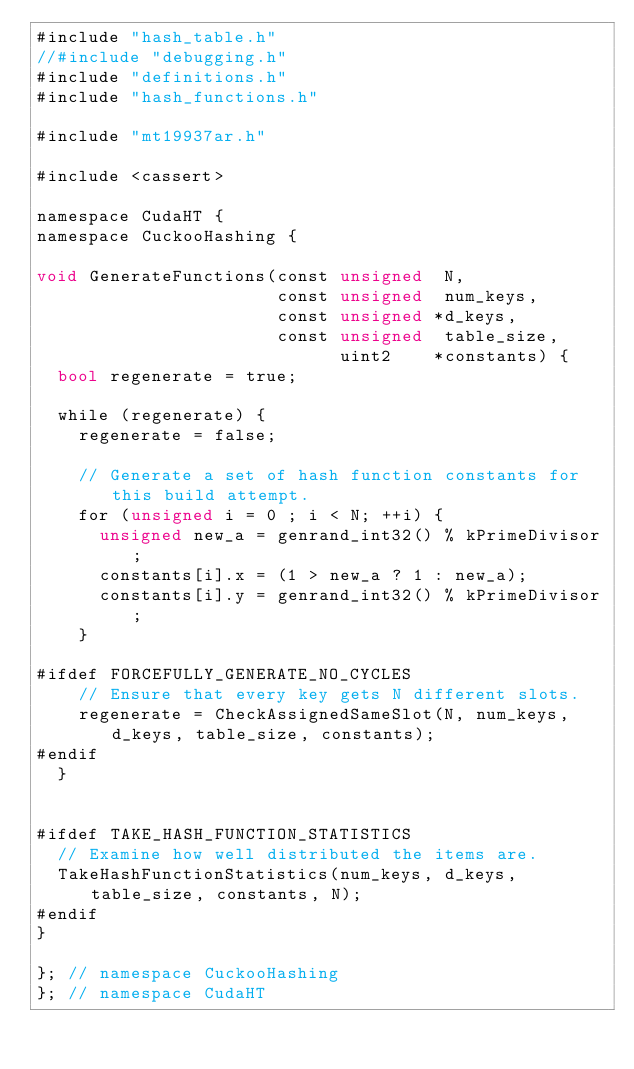Convert code to text. <code><loc_0><loc_0><loc_500><loc_500><_Cuda_>#include "hash_table.h"
//#include "debugging.h"
#include "definitions.h"
#include "hash_functions.h"

#include "mt19937ar.h"

#include <cassert>

namespace CudaHT {
namespace CuckooHashing {

void GenerateFunctions(const unsigned  N,
                       const unsigned  num_keys,
                       const unsigned *d_keys,
                       const unsigned  table_size,
                             uint2    *constants) {
  bool regenerate = true;

  while (regenerate) {
    regenerate = false;

    // Generate a set of hash function constants for this build attempt.
    for (unsigned i = 0 ; i < N; ++i) {
      unsigned new_a = genrand_int32() % kPrimeDivisor;
      constants[i].x = (1 > new_a ? 1 : new_a);
      constants[i].y = genrand_int32() % kPrimeDivisor;
    }

#ifdef FORCEFULLY_GENERATE_NO_CYCLES
    // Ensure that every key gets N different slots.
    regenerate = CheckAssignedSameSlot(N, num_keys, d_keys, table_size, constants);
#endif
  }


#ifdef TAKE_HASH_FUNCTION_STATISTICS
  // Examine how well distributed the items are.
  TakeHashFunctionStatistics(num_keys, d_keys, table_size, constants, N);
#endif
}

}; // namespace CuckooHashing
}; // namespace CudaHT
</code> 